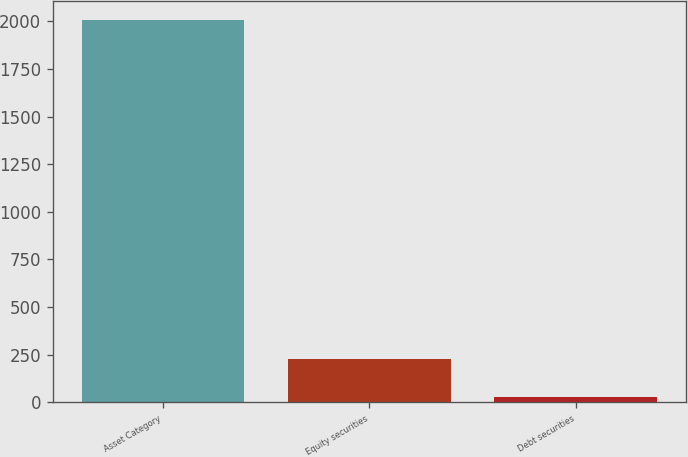<chart> <loc_0><loc_0><loc_500><loc_500><bar_chart><fcel>Asset Category<fcel>Equity securities<fcel>Debt securities<nl><fcel>2007<fcel>227.7<fcel>30<nl></chart> 